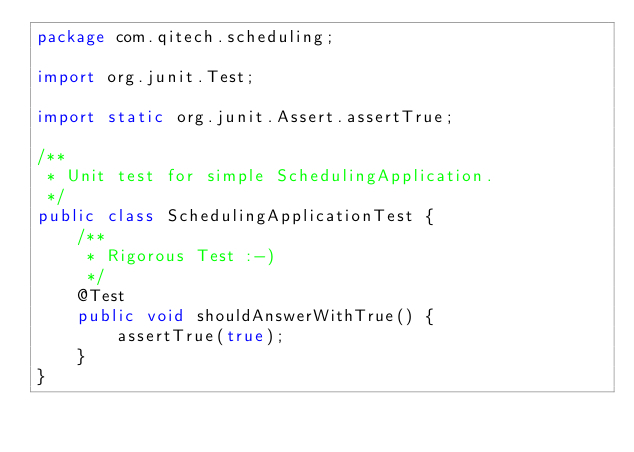Convert code to text. <code><loc_0><loc_0><loc_500><loc_500><_Java_>package com.qitech.scheduling;

import org.junit.Test;

import static org.junit.Assert.assertTrue;

/**
 * Unit test for simple SchedulingApplication.
 */
public class SchedulingApplicationTest {
    /**
     * Rigorous Test :-)
     */
    @Test
    public void shouldAnswerWithTrue() {
        assertTrue(true);
    }
}
</code> 